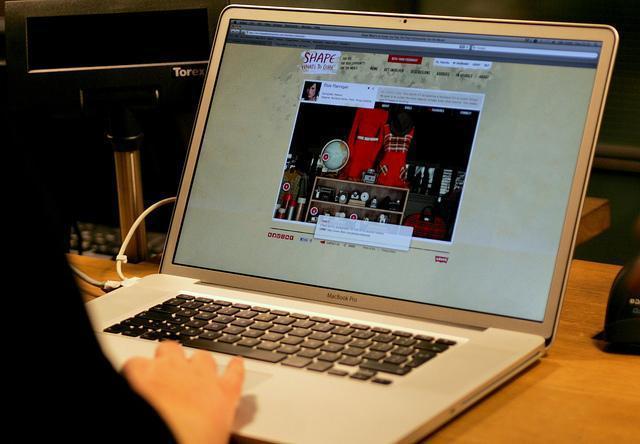How many people are shown on the computer?
Give a very brief answer. 2. How many motorcycles are in the picture?
Give a very brief answer. 0. 